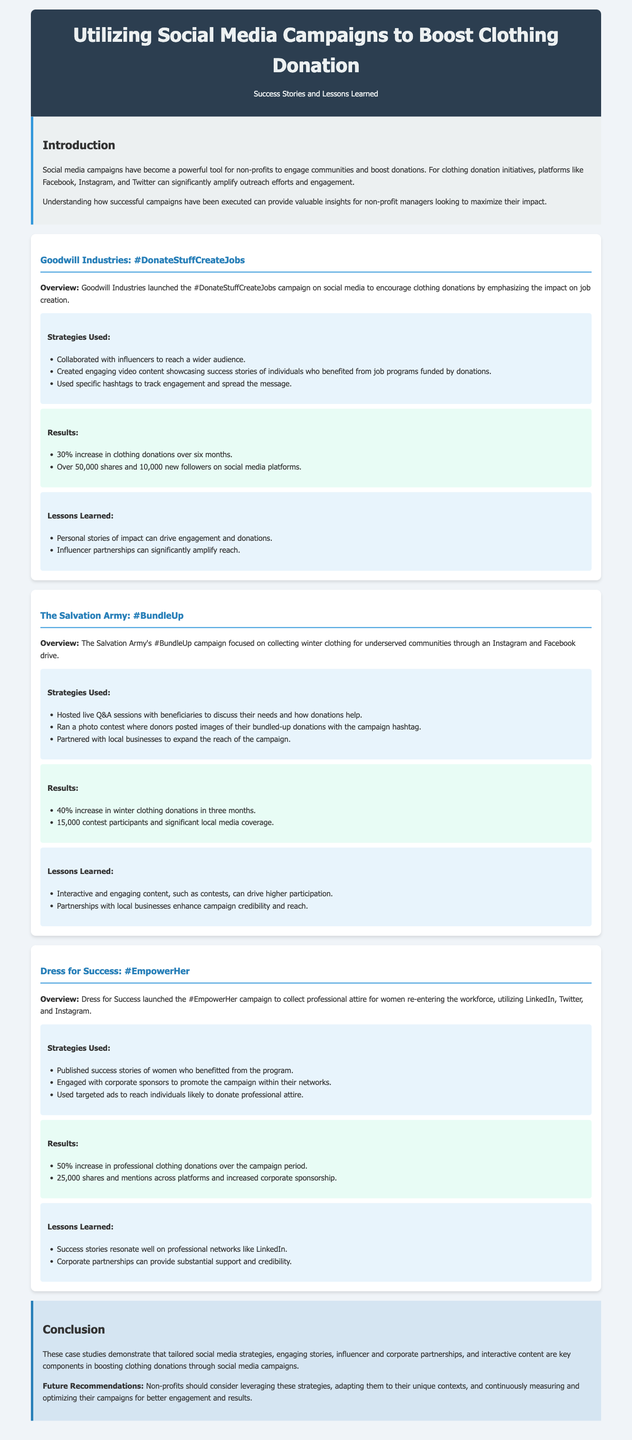What was the increase in clothing donations for Goodwill Industries after six months? The document states a 30% increase in clothing donations for Goodwill Industries over six months.
Answer: 30% What campaign did The Salvation Army run for collecting winter clothing? The campaign run by The Salvation Army was called #BundleUp.
Answer: #BundleUp How many shares and mentions did the #EmpowerHer campaign receive? The document indicates that the #EmpowerHer campaign received 25,000 shares and mentions across platforms.
Answer: 25,000 What key component was emphasized in the conclusion for boosting clothing donations? The conclusion emphasizes tailored social media strategies as a key component in boosting clothing donations.
Answer: tailored social media strategies Which social media platform did Dress for Success primarily utilize for their campaign? Dress for Success utilized LinkedIn for their #EmpowerHer campaign.
Answer: LinkedIn What percentage increase in winter clothing donations did The Salvation Army achieve in three months? The document mentions a 40% increase in winter clothing donations achieved by The Salvation Army in three months.
Answer: 40% What type of content did Goodwill Industries use to drive engagement in their campaign? Goodwill Industries used engaging video content showcasing success stories to drive engagement in their campaign.
Answer: engaging video content Which strategy was common among all case studies to enhance donations? The common strategy across all case studies was the use of social media campaigns to enhance donations.
Answer: social media campaigns 